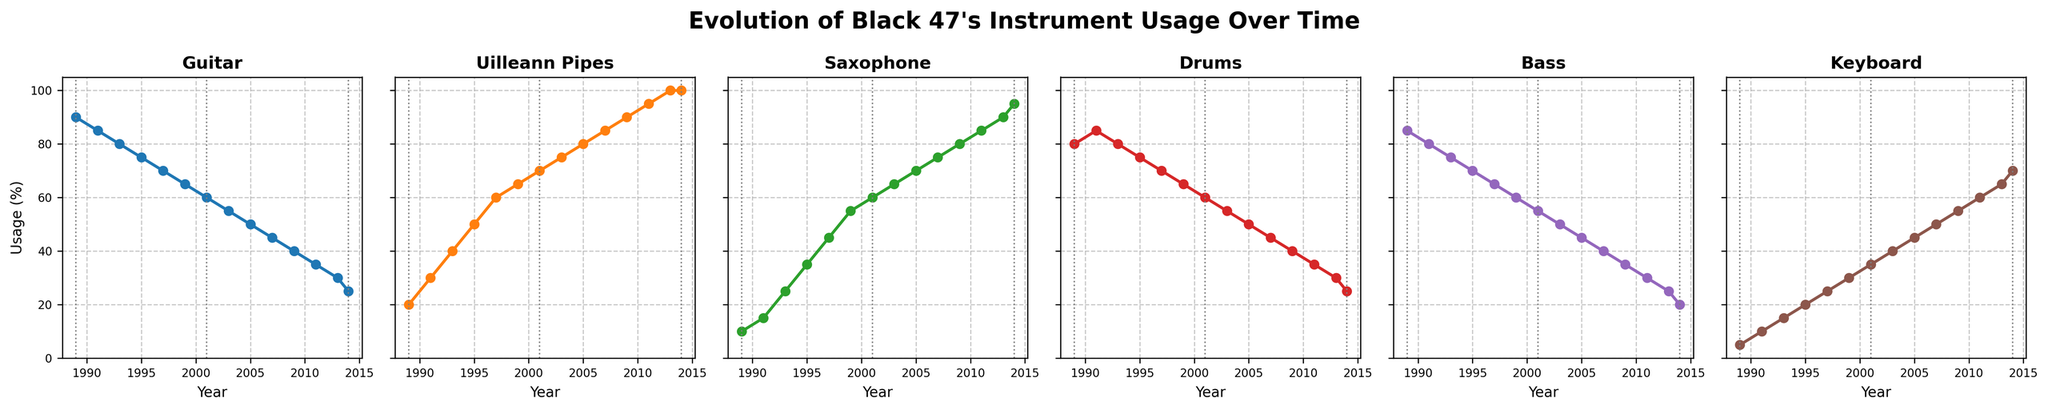What trend do you notice in the usage of Uilleann Pipes from 1989 to 2014? The usage of Uilleann Pipes consistently increases over time, starting from 20% in 1989 and reaching 100% in 2013 and 2014.
Answer: It increases steadily Which instrument had the most stable usage across the years? Looking at the plot lines, the Drums have the most stable usage, hovering around 80-60% across the years.
Answer: Drums By 2014, which instrument saw the greatest decrease in usage compared to 1989? Comparing the beginning and end points for each instrument, the Guitar usage decreased from 90% in 1989 to 25% in 2014, a drop of 65%.
Answer: Guitar Did the Bass usage ever increase after 1989? If yes, in which periods did the increase occur? The Bass usage increased from 1989 to 1991, then again from 2001 to 2003.
Answer: 1989-1991, 2001-2003 In which year did the Keyboard usage first surpass the Guitar usage? By looking at the intersection points on the plots, the Keyboard usage first surpassed the Guitar usage in 2011, where Keyboard was at 60% and Guitar was at 35%.
Answer: 2011 Which years are highlighted with vertical gray lines, and what might be their significance? The vertical gray lines mark the years 1989, 2001, and 2014. These years might indicate significant points in Black 47's evolution or key events in their career.
Answer: 1989, 2001, 2014 Which instrument’s usage reached 100% by 2013 and stayed the same in 2014? The Uilleann Pipes reached 100% usage by 2013 and remained the same in 2014.
Answer: Uilleann Pipes Compare the trend of Saxophone and Bass from 1989 to 2014. Which one had a more drastic change? Observing both plots, the Saxophone's usage increases steeply from 10% to 95%, whereas the Bass shows a consistent decline from 85% to 20%. The Saxophone change is more drastic.
Answer: Saxophone During which periods did the Keyboard usage increase the fastest? The plot shows the Keyboard usage increased most rapidly between 2005 and 2014.
Answer: 2005-2014 What is the average usage percentage of the Drums over the entire period? Adding all the Drums usage percentages from each year and dividing by the number of years: (80+85+80+75+70+65+60+55+50+45+40+35+30+25)/14 ≈ 57.14%
Answer: 57.14% 